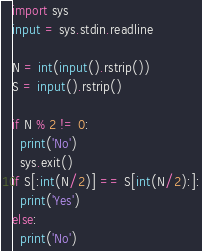Convert code to text. <code><loc_0><loc_0><loc_500><loc_500><_Python_>import sys
input = sys.stdin.readline

N = int(input().rstrip())
S = input().rstrip()

if N % 2 != 0:
  print('No')
  sys.exit()
if S[:int(N/2)] == S[int(N/2):]:
  print('Yes')
else:
  print('No')
</code> 